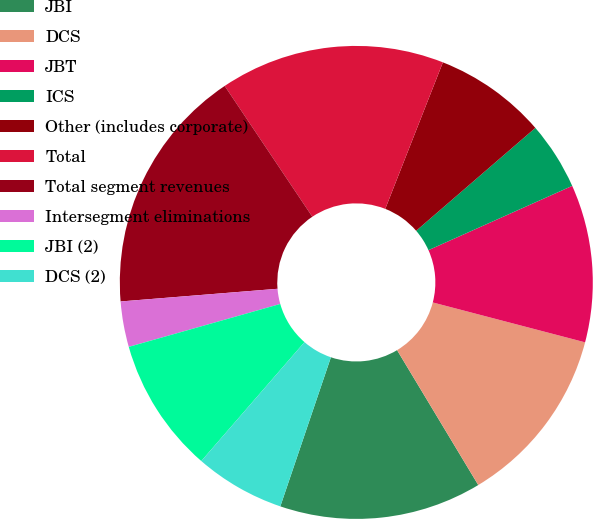Convert chart to OTSL. <chart><loc_0><loc_0><loc_500><loc_500><pie_chart><fcel>JBI<fcel>DCS<fcel>JBT<fcel>ICS<fcel>Other (includes corporate)<fcel>Total<fcel>Total segment revenues<fcel>Intersegment eliminations<fcel>JBI (2)<fcel>DCS (2)<nl><fcel>13.83%<fcel>12.3%<fcel>10.77%<fcel>4.64%<fcel>7.7%<fcel>15.36%<fcel>16.89%<fcel>3.11%<fcel>9.23%<fcel>6.17%<nl></chart> 